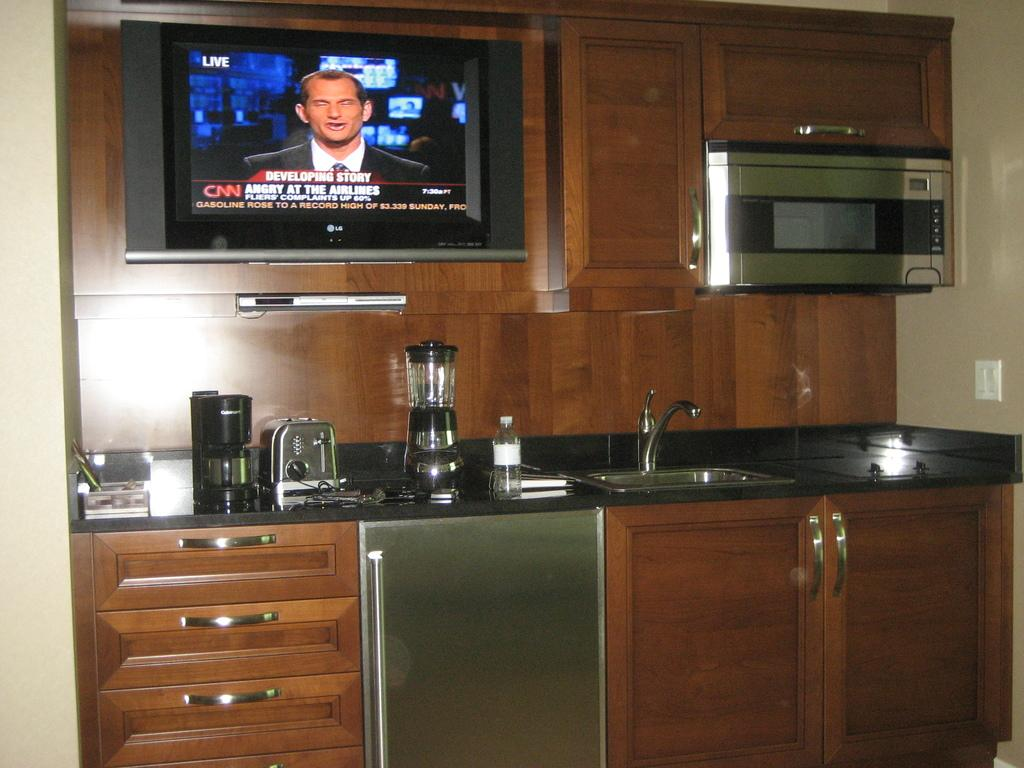<image>
Create a compact narrative representing the image presented. a tv in a kitchen turned to CNN's breaking news 